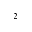<formula> <loc_0><loc_0><loc_500><loc_500>^ { 2 }</formula> 